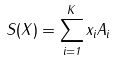<formula> <loc_0><loc_0><loc_500><loc_500>S ( X ) = \sum _ { i = 1 } ^ { K } x _ { i } A _ { i }</formula> 